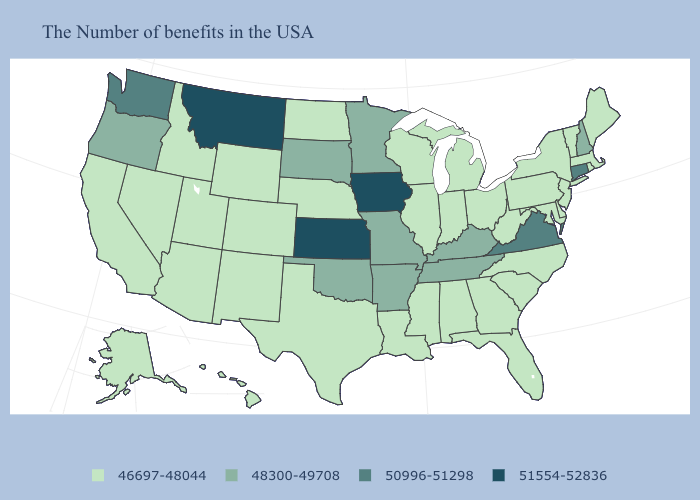Which states have the lowest value in the West?
Be succinct. Wyoming, Colorado, New Mexico, Utah, Arizona, Idaho, Nevada, California, Alaska, Hawaii. How many symbols are there in the legend?
Answer briefly. 4. What is the highest value in the South ?
Keep it brief. 50996-51298. What is the highest value in the USA?
Write a very short answer. 51554-52836. Which states have the lowest value in the USA?
Quick response, please. Maine, Massachusetts, Rhode Island, Vermont, New York, New Jersey, Delaware, Maryland, Pennsylvania, North Carolina, South Carolina, West Virginia, Ohio, Florida, Georgia, Michigan, Indiana, Alabama, Wisconsin, Illinois, Mississippi, Louisiana, Nebraska, Texas, North Dakota, Wyoming, Colorado, New Mexico, Utah, Arizona, Idaho, Nevada, California, Alaska, Hawaii. What is the value of Nebraska?
Short answer required. 46697-48044. Which states have the lowest value in the USA?
Answer briefly. Maine, Massachusetts, Rhode Island, Vermont, New York, New Jersey, Delaware, Maryland, Pennsylvania, North Carolina, South Carolina, West Virginia, Ohio, Florida, Georgia, Michigan, Indiana, Alabama, Wisconsin, Illinois, Mississippi, Louisiana, Nebraska, Texas, North Dakota, Wyoming, Colorado, New Mexico, Utah, Arizona, Idaho, Nevada, California, Alaska, Hawaii. What is the value of Arizona?
Give a very brief answer. 46697-48044. What is the highest value in the USA?
Keep it brief. 51554-52836. Among the states that border Oklahoma , does Arkansas have the lowest value?
Short answer required. No. What is the value of Louisiana?
Concise answer only. 46697-48044. What is the value of Michigan?
Answer briefly. 46697-48044. Name the states that have a value in the range 46697-48044?
Be succinct. Maine, Massachusetts, Rhode Island, Vermont, New York, New Jersey, Delaware, Maryland, Pennsylvania, North Carolina, South Carolina, West Virginia, Ohio, Florida, Georgia, Michigan, Indiana, Alabama, Wisconsin, Illinois, Mississippi, Louisiana, Nebraska, Texas, North Dakota, Wyoming, Colorado, New Mexico, Utah, Arizona, Idaho, Nevada, California, Alaska, Hawaii. What is the value of Ohio?
Be succinct. 46697-48044. Which states have the lowest value in the Northeast?
Answer briefly. Maine, Massachusetts, Rhode Island, Vermont, New York, New Jersey, Pennsylvania. 